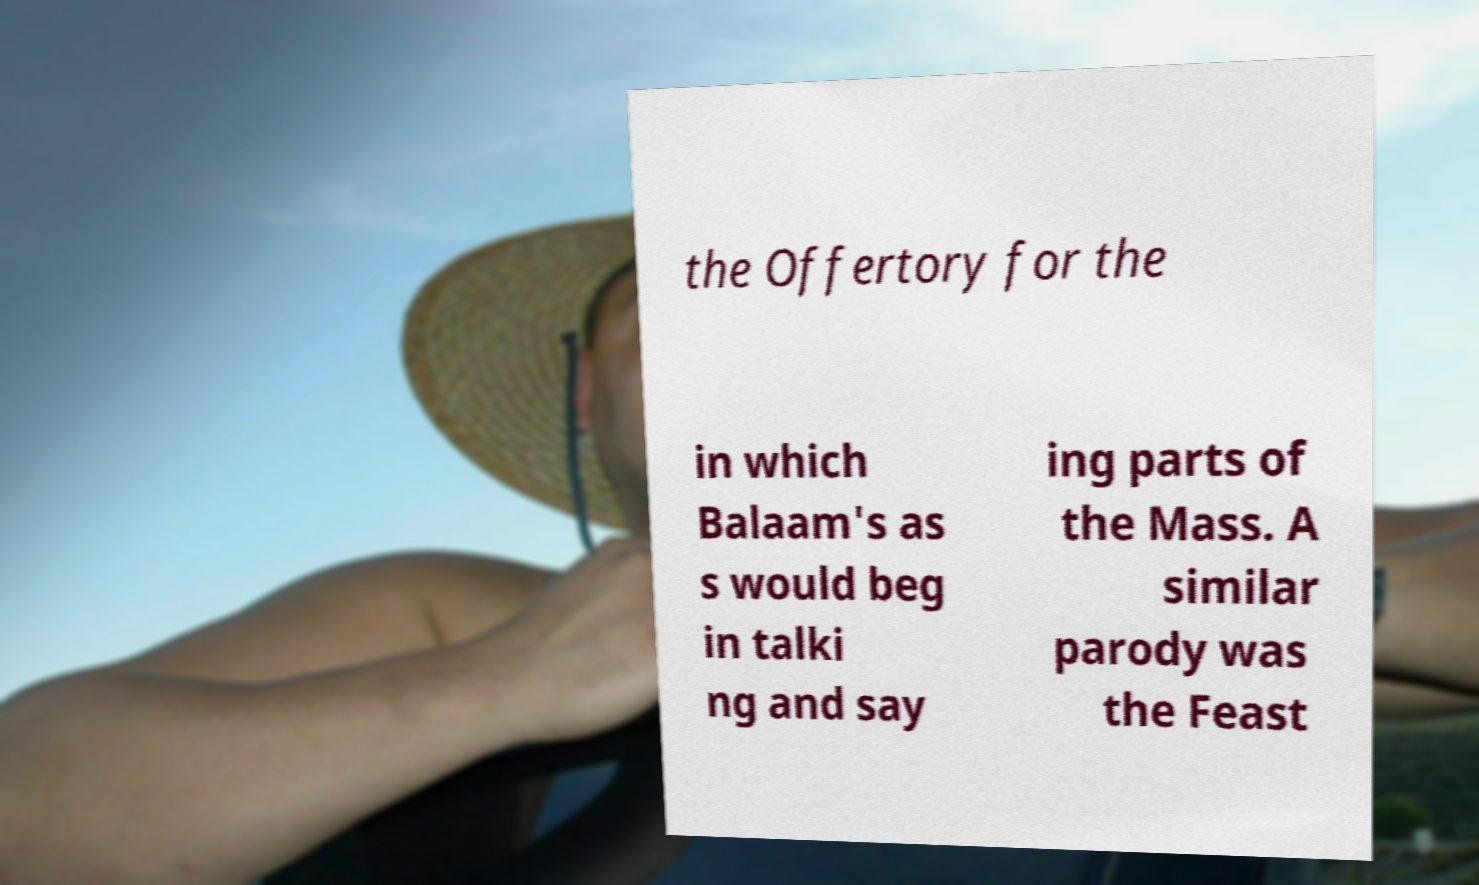Please read and relay the text visible in this image. What does it say? the Offertory for the in which Balaam's as s would beg in talki ng and say ing parts of the Mass. A similar parody was the Feast 